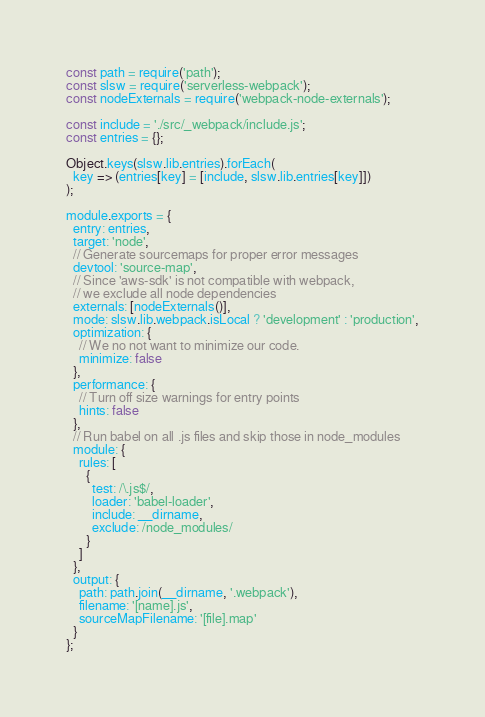Convert code to text. <code><loc_0><loc_0><loc_500><loc_500><_JavaScript_>const path = require('path');
const slsw = require('serverless-webpack');
const nodeExternals = require('webpack-node-externals');

const include = './src/_webpack/include.js';
const entries = {};

Object.keys(slsw.lib.entries).forEach(
  key => (entries[key] = [include, slsw.lib.entries[key]])
);

module.exports = {
  entry: entries,
  target: 'node',
  // Generate sourcemaps for proper error messages
  devtool: 'source-map',
  // Since 'aws-sdk' is not compatible with webpack,
  // we exclude all node dependencies
  externals: [nodeExternals()],
  mode: slsw.lib.webpack.isLocal ? 'development' : 'production',
  optimization: {
    // We no not want to minimize our code.
    minimize: false
  },
  performance: {
    // Turn off size warnings for entry points
    hints: false
  },
  // Run babel on all .js files and skip those in node_modules
  module: {
    rules: [
      {
        test: /\.js$/,
        loader: 'babel-loader',
        include: __dirname,
        exclude: /node_modules/
      }
    ]
  },
  output: {
    path: path.join(__dirname, '.webpack'),
    filename: '[name].js',
    sourceMapFilename: '[file].map'
  }
};
</code> 